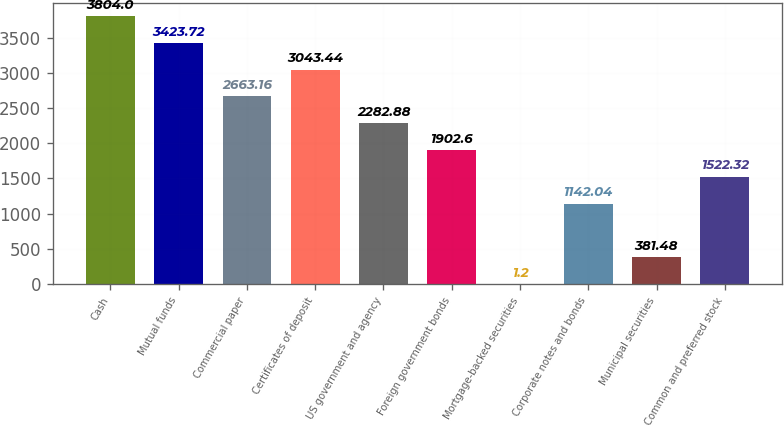Convert chart to OTSL. <chart><loc_0><loc_0><loc_500><loc_500><bar_chart><fcel>Cash<fcel>Mutual funds<fcel>Commercial paper<fcel>Certificates of deposit<fcel>US government and agency<fcel>Foreign government bonds<fcel>Mortgage-backed securities<fcel>Corporate notes and bonds<fcel>Municipal securities<fcel>Common and preferred stock<nl><fcel>3804<fcel>3423.72<fcel>2663.16<fcel>3043.44<fcel>2282.88<fcel>1902.6<fcel>1.2<fcel>1142.04<fcel>381.48<fcel>1522.32<nl></chart> 